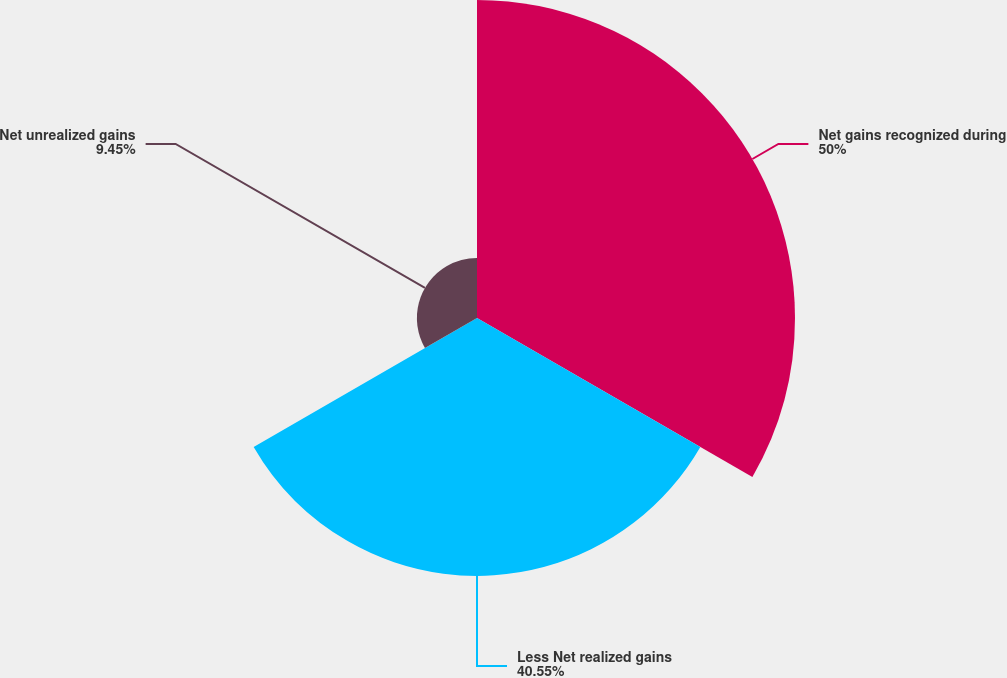<chart> <loc_0><loc_0><loc_500><loc_500><pie_chart><fcel>Net gains recognized during<fcel>Less Net realized gains<fcel>Net unrealized gains<nl><fcel>50.0%<fcel>40.55%<fcel>9.45%<nl></chart> 